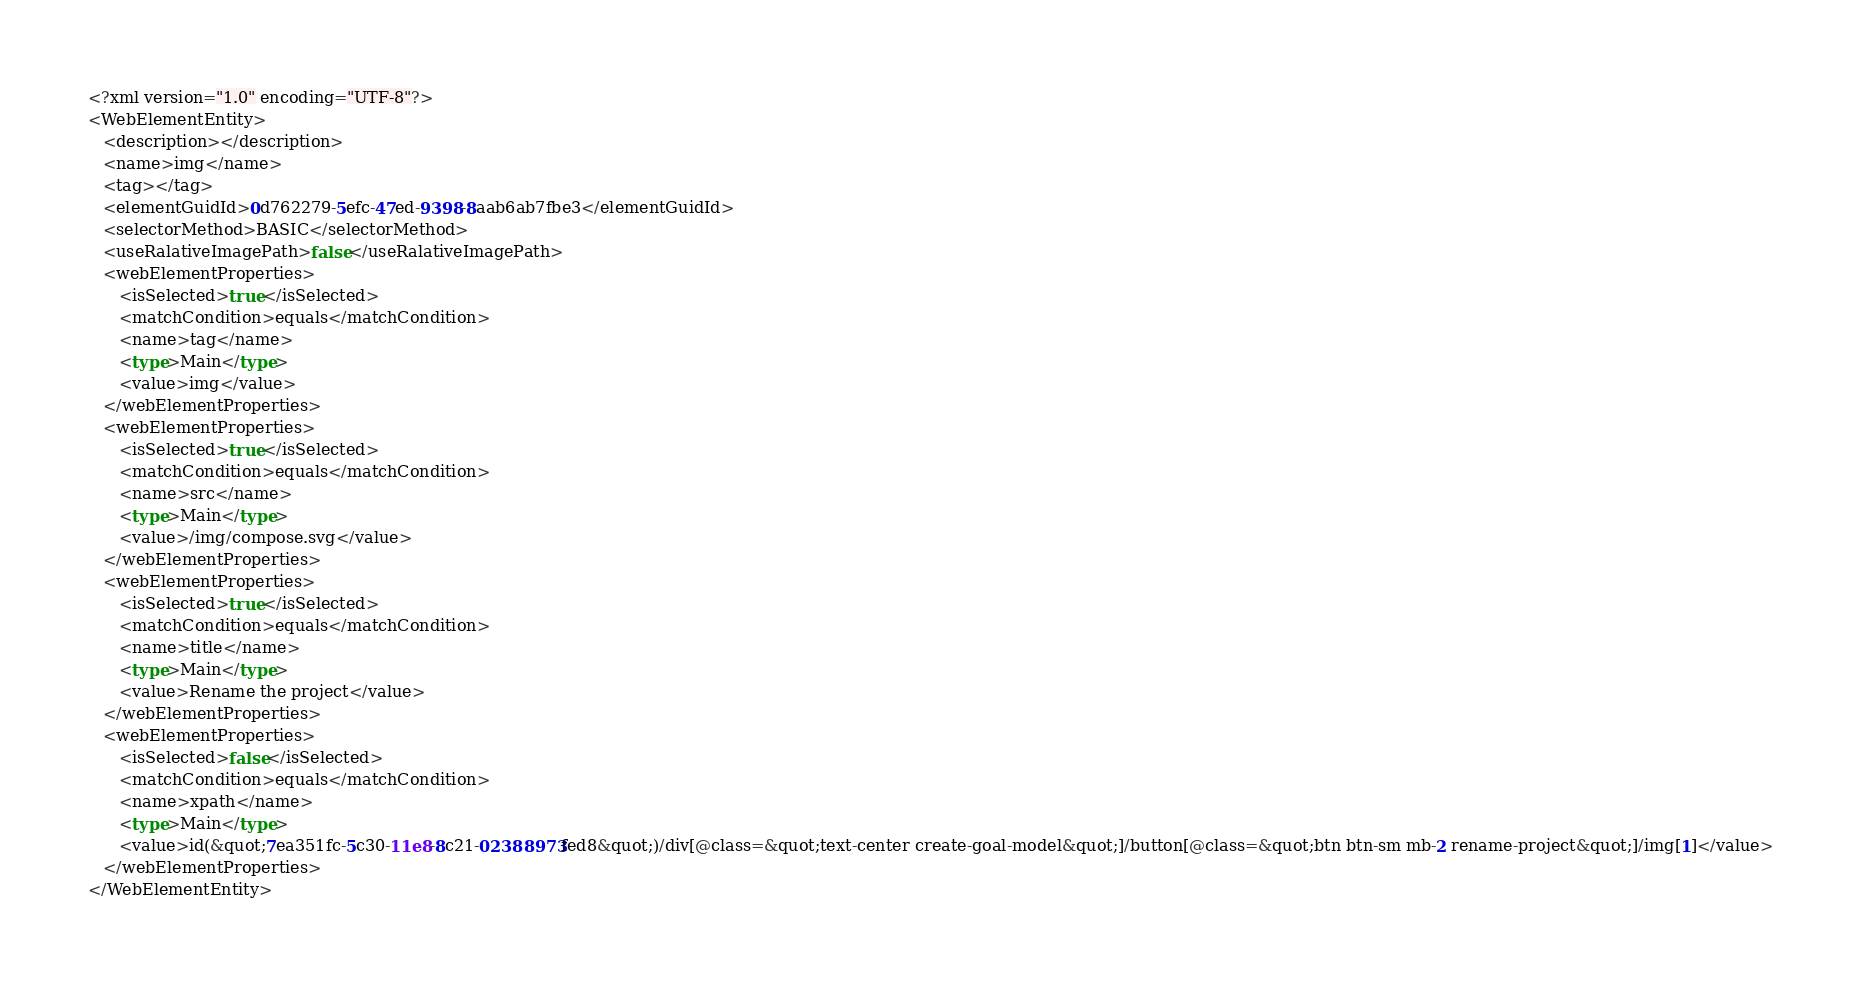<code> <loc_0><loc_0><loc_500><loc_500><_Rust_><?xml version="1.0" encoding="UTF-8"?>
<WebElementEntity>
   <description></description>
   <name>img</name>
   <tag></tag>
   <elementGuidId>0d762279-5efc-47ed-9398-8aab6ab7fbe3</elementGuidId>
   <selectorMethod>BASIC</selectorMethod>
   <useRalativeImagePath>false</useRalativeImagePath>
   <webElementProperties>
      <isSelected>true</isSelected>
      <matchCondition>equals</matchCondition>
      <name>tag</name>
      <type>Main</type>
      <value>img</value>
   </webElementProperties>
   <webElementProperties>
      <isSelected>true</isSelected>
      <matchCondition>equals</matchCondition>
      <name>src</name>
      <type>Main</type>
      <value>/img/compose.svg</value>
   </webElementProperties>
   <webElementProperties>
      <isSelected>true</isSelected>
      <matchCondition>equals</matchCondition>
      <name>title</name>
      <type>Main</type>
      <value>Rename the project</value>
   </webElementProperties>
   <webElementProperties>
      <isSelected>false</isSelected>
      <matchCondition>equals</matchCondition>
      <name>xpath</name>
      <type>Main</type>
      <value>id(&quot;7ea351fc-5c30-11e8-8c21-02388973fed8&quot;)/div[@class=&quot;text-center create-goal-model&quot;]/button[@class=&quot;btn btn-sm mb-2 rename-project&quot;]/img[1]</value>
   </webElementProperties>
</WebElementEntity>
</code> 